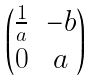<formula> <loc_0><loc_0><loc_500><loc_500>\begin{pmatrix} \frac { 1 } { a } & - b \\ 0 & a \end{pmatrix}</formula> 